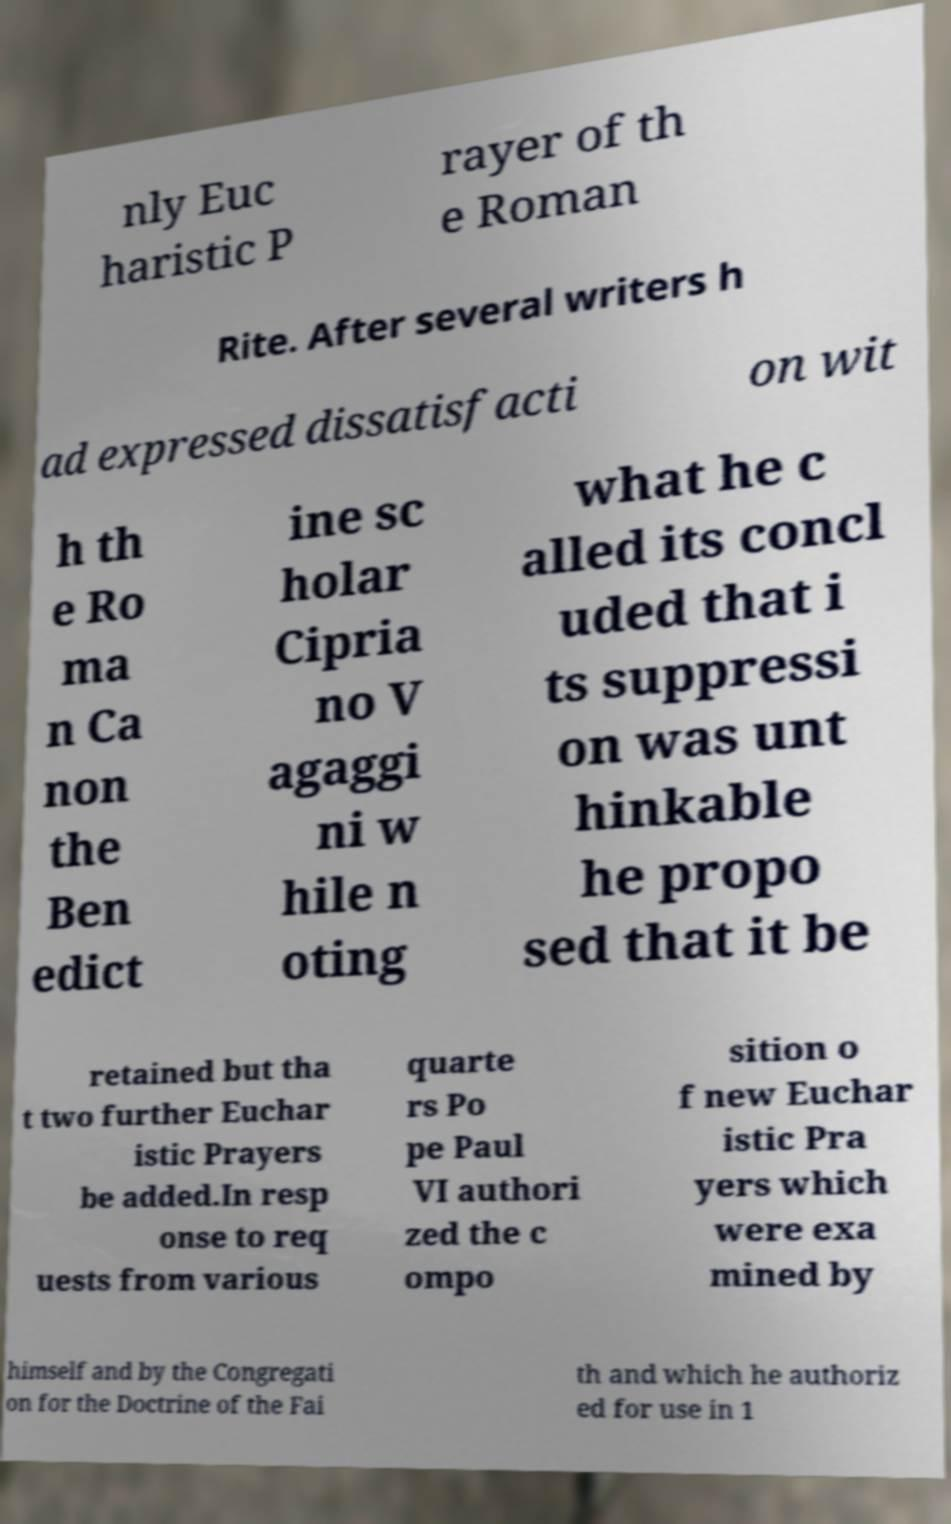I need the written content from this picture converted into text. Can you do that? nly Euc haristic P rayer of th e Roman Rite. After several writers h ad expressed dissatisfacti on wit h th e Ro ma n Ca non the Ben edict ine sc holar Cipria no V agaggi ni w hile n oting what he c alled its concl uded that i ts suppressi on was unt hinkable he propo sed that it be retained but tha t two further Euchar istic Prayers be added.In resp onse to req uests from various quarte rs Po pe Paul VI authori zed the c ompo sition o f new Euchar istic Pra yers which were exa mined by himself and by the Congregati on for the Doctrine of the Fai th and which he authoriz ed for use in 1 